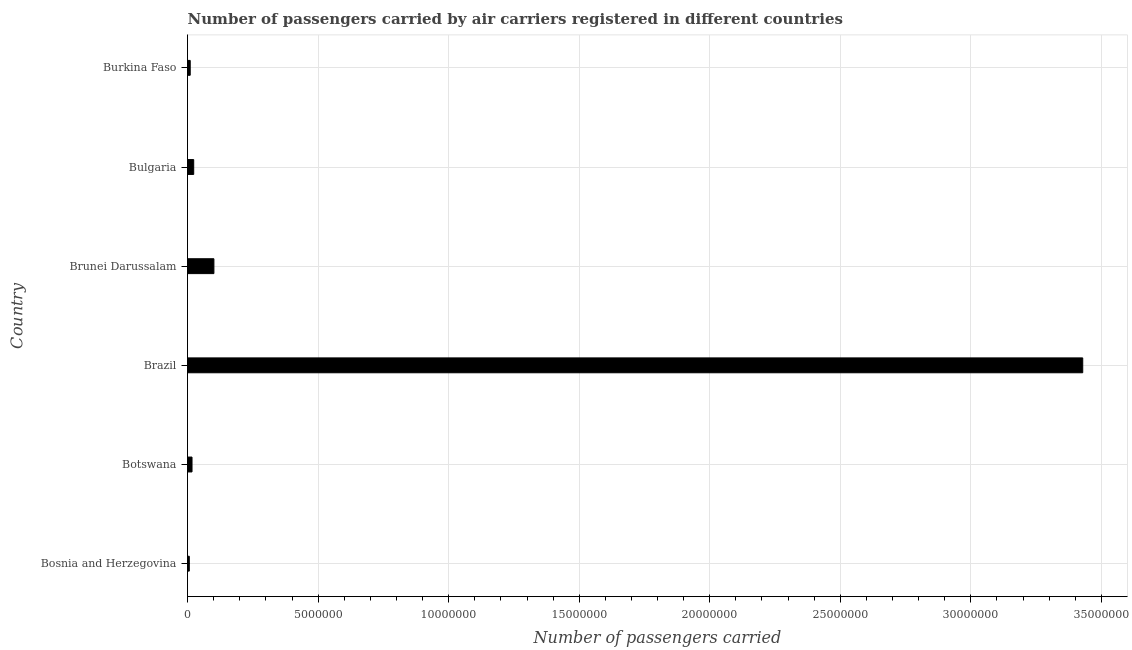What is the title of the graph?
Ensure brevity in your answer.  Number of passengers carried by air carriers registered in different countries. What is the label or title of the X-axis?
Your response must be concise. Number of passengers carried. What is the number of passengers carried in Bosnia and Herzegovina?
Your answer should be compact. 6.50e+04. Across all countries, what is the maximum number of passengers carried?
Offer a very short reply. 3.43e+07. Across all countries, what is the minimum number of passengers carried?
Make the answer very short. 6.50e+04. In which country was the number of passengers carried maximum?
Your answer should be very brief. Brazil. In which country was the number of passengers carried minimum?
Your response must be concise. Bosnia and Herzegovina. What is the sum of the number of passengers carried?
Your answer should be very brief. 3.59e+07. What is the difference between the number of passengers carried in Botswana and Brazil?
Your response must be concise. -3.41e+07. What is the average number of passengers carried per country?
Your answer should be compact. 5.98e+06. What is the median number of passengers carried?
Your answer should be very brief. 2.02e+05. In how many countries, is the number of passengers carried greater than 29000000 ?
Keep it short and to the point. 1. What is the ratio of the number of passengers carried in Brunei Darussalam to that in Burkina Faso?
Provide a succinct answer. 10.05. Is the number of passengers carried in Brazil less than that in Brunei Darussalam?
Your answer should be compact. No. What is the difference between the highest and the second highest number of passengers carried?
Keep it short and to the point. 3.33e+07. What is the difference between the highest and the lowest number of passengers carried?
Keep it short and to the point. 3.42e+07. In how many countries, is the number of passengers carried greater than the average number of passengers carried taken over all countries?
Your response must be concise. 1. Are all the bars in the graph horizontal?
Your response must be concise. Yes. What is the Number of passengers carried of Bosnia and Herzegovina?
Your answer should be very brief. 6.50e+04. What is the Number of passengers carried of Botswana?
Your answer should be very brief. 1.70e+05. What is the Number of passengers carried of Brazil?
Your answer should be compact. 3.43e+07. What is the Number of passengers carried of Brunei Darussalam?
Your answer should be very brief. 1.01e+06. What is the Number of passengers carried in Bulgaria?
Provide a succinct answer. 2.34e+05. What is the Number of passengers carried of Burkina Faso?
Make the answer very short. 1.00e+05. What is the difference between the Number of passengers carried in Bosnia and Herzegovina and Botswana?
Your answer should be compact. -1.05e+05. What is the difference between the Number of passengers carried in Bosnia and Herzegovina and Brazil?
Keep it short and to the point. -3.42e+07. What is the difference between the Number of passengers carried in Bosnia and Herzegovina and Brunei Darussalam?
Keep it short and to the point. -9.43e+05. What is the difference between the Number of passengers carried in Bosnia and Herzegovina and Bulgaria?
Make the answer very short. -1.69e+05. What is the difference between the Number of passengers carried in Bosnia and Herzegovina and Burkina Faso?
Give a very brief answer. -3.53e+04. What is the difference between the Number of passengers carried in Botswana and Brazil?
Make the answer very short. -3.41e+07. What is the difference between the Number of passengers carried in Botswana and Brunei Darussalam?
Keep it short and to the point. -8.38e+05. What is the difference between the Number of passengers carried in Botswana and Bulgaria?
Provide a succinct answer. -6.44e+04. What is the difference between the Number of passengers carried in Botswana and Burkina Faso?
Give a very brief answer. 6.92e+04. What is the difference between the Number of passengers carried in Brazil and Brunei Darussalam?
Offer a terse response. 3.33e+07. What is the difference between the Number of passengers carried in Brazil and Bulgaria?
Provide a succinct answer. 3.41e+07. What is the difference between the Number of passengers carried in Brazil and Burkina Faso?
Provide a short and direct response. 3.42e+07. What is the difference between the Number of passengers carried in Brunei Darussalam and Bulgaria?
Give a very brief answer. 7.74e+05. What is the difference between the Number of passengers carried in Brunei Darussalam and Burkina Faso?
Your answer should be very brief. 9.07e+05. What is the difference between the Number of passengers carried in Bulgaria and Burkina Faso?
Your response must be concise. 1.34e+05. What is the ratio of the Number of passengers carried in Bosnia and Herzegovina to that in Botswana?
Offer a very short reply. 0.38. What is the ratio of the Number of passengers carried in Bosnia and Herzegovina to that in Brazil?
Provide a short and direct response. 0. What is the ratio of the Number of passengers carried in Bosnia and Herzegovina to that in Brunei Darussalam?
Your answer should be very brief. 0.07. What is the ratio of the Number of passengers carried in Bosnia and Herzegovina to that in Bulgaria?
Your response must be concise. 0.28. What is the ratio of the Number of passengers carried in Bosnia and Herzegovina to that in Burkina Faso?
Provide a succinct answer. 0.65. What is the ratio of the Number of passengers carried in Botswana to that in Brazil?
Offer a very short reply. 0.01. What is the ratio of the Number of passengers carried in Botswana to that in Brunei Darussalam?
Your answer should be compact. 0.17. What is the ratio of the Number of passengers carried in Botswana to that in Bulgaria?
Your answer should be very brief. 0.72. What is the ratio of the Number of passengers carried in Botswana to that in Burkina Faso?
Make the answer very short. 1.69. What is the ratio of the Number of passengers carried in Brazil to that in Brunei Darussalam?
Your answer should be very brief. 34.03. What is the ratio of the Number of passengers carried in Brazil to that in Bulgaria?
Keep it short and to the point. 146.54. What is the ratio of the Number of passengers carried in Brazil to that in Burkina Faso?
Offer a very short reply. 341.88. What is the ratio of the Number of passengers carried in Brunei Darussalam to that in Bulgaria?
Your answer should be very brief. 4.31. What is the ratio of the Number of passengers carried in Brunei Darussalam to that in Burkina Faso?
Offer a very short reply. 10.05. What is the ratio of the Number of passengers carried in Bulgaria to that in Burkina Faso?
Your response must be concise. 2.33. 